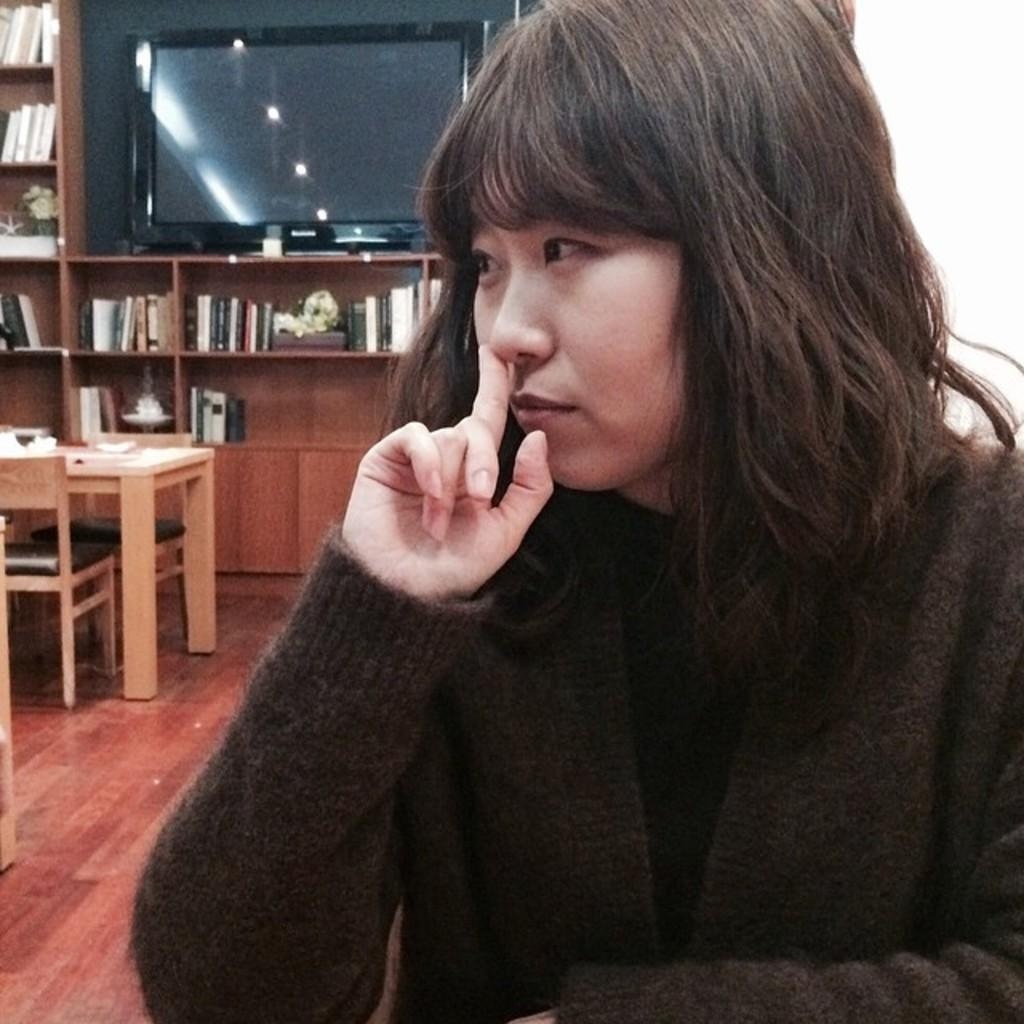What is the person in the image doing? The person is sitting in the image. What can be seen in the background of the image? There is a TV, a table, and a chair in the background of the image. How many plants are on the table in the image? There are no plants mentioned or visible in the image. Are the person's brothers present in the image? There is no information about the person's brothers in the image or the provided facts. 